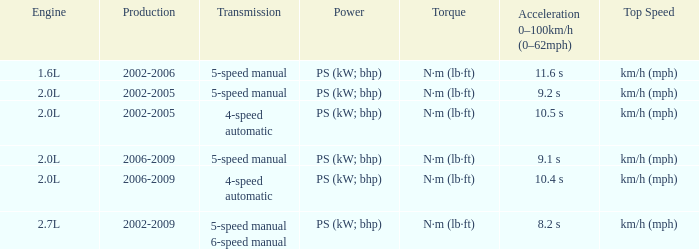What is the top speed of a 5-speed manual transmission produced in 2006-2009? Km/h (mph). 